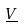Convert formula to latex. <formula><loc_0><loc_0><loc_500><loc_500>\underline { V }</formula> 